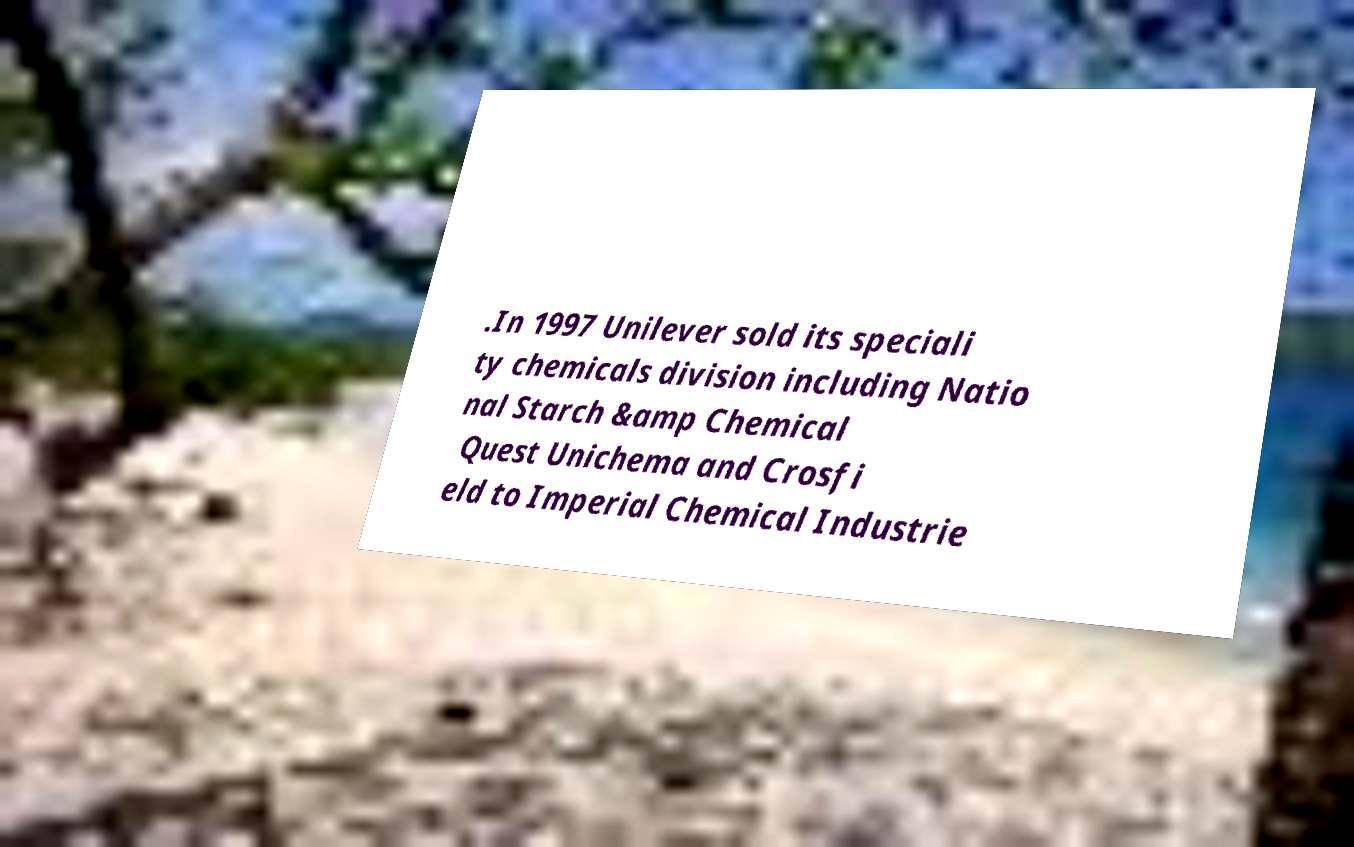Please identify and transcribe the text found in this image. .In 1997 Unilever sold its speciali ty chemicals division including Natio nal Starch &amp Chemical Quest Unichema and Crosfi eld to Imperial Chemical Industrie 